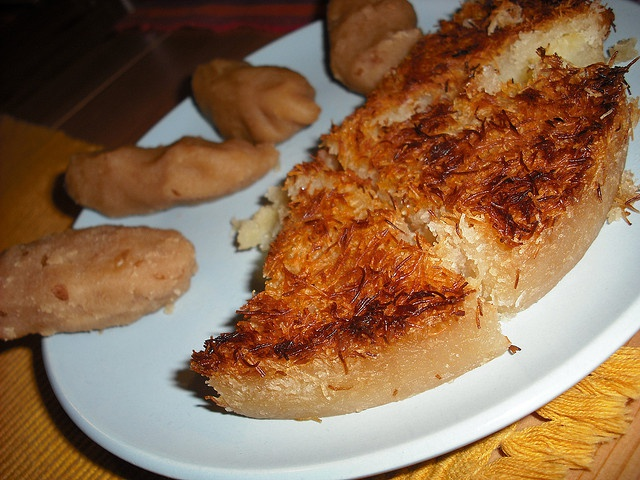Describe the objects in this image and their specific colors. I can see pizza in black, maroon, brown, and tan tones and pizza in black, red, tan, and maroon tones in this image. 